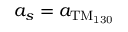Convert formula to latex. <formula><loc_0><loc_0><loc_500><loc_500>a _ { s } = a _ { T M _ { 1 3 0 } }</formula> 